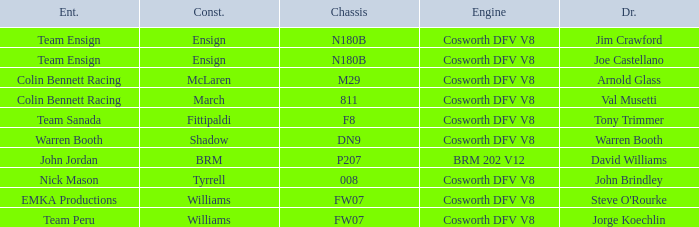What team used the BRM built car? John Jordan. 